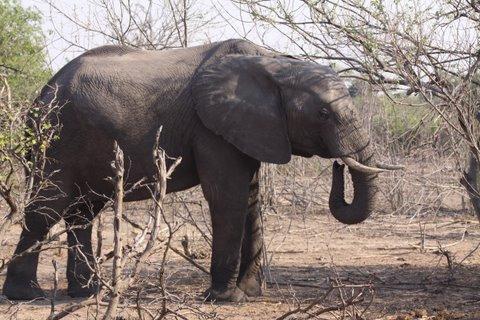Is this animal a mammal?
Give a very brief answer. Yes. What is this animal doing?
Short answer required. Standing. What kind of animal is this?
Keep it brief. Elephant. 